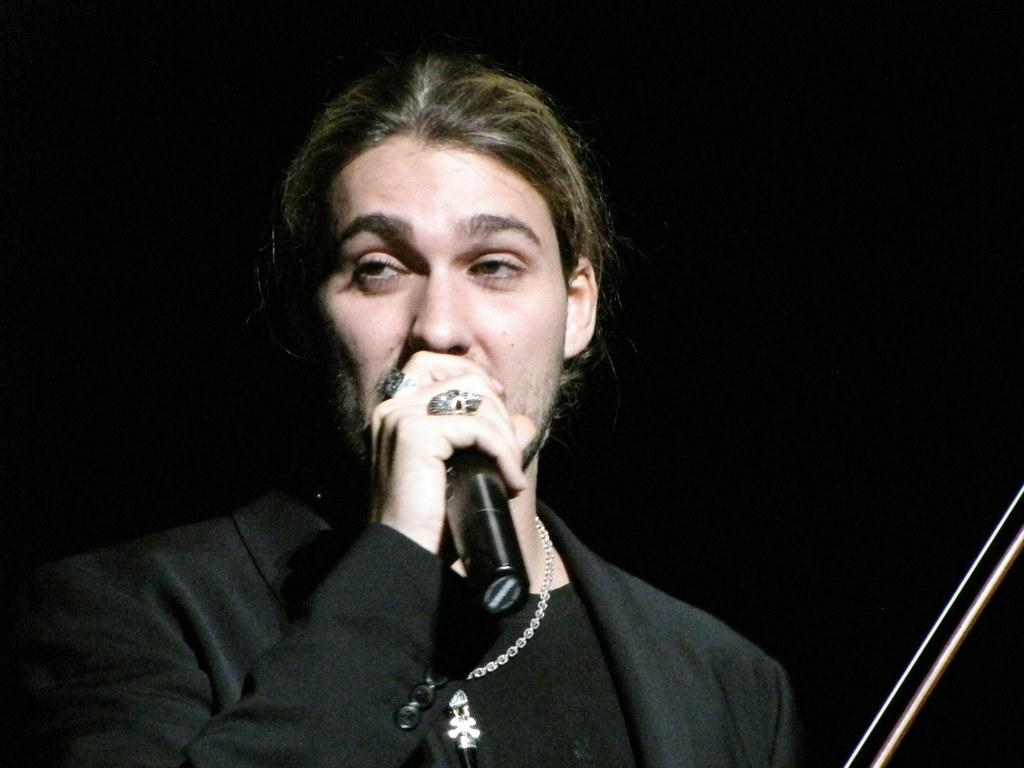Who is the main subject in the image? There is a man in the image. What is the man holding in the image? The man is holding a microphone. What color is the background of the image? The background of the image is black. What type of detail can be seen on the carpenter's tool in the image? There is no carpenter or tool present in the image. How many planes are visible in the image? There are no planes visible in the image. 